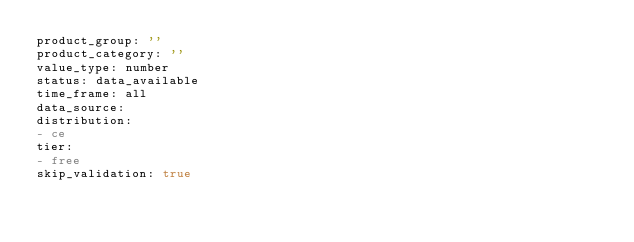Convert code to text. <code><loc_0><loc_0><loc_500><loc_500><_YAML_>product_group: ''
product_category: ''
value_type: number
status: data_available
time_frame: all
data_source:
distribution:
- ce
tier:
- free
skip_validation: true
</code> 